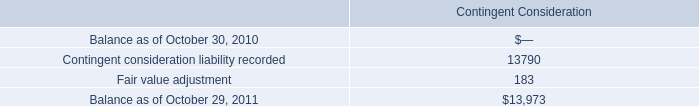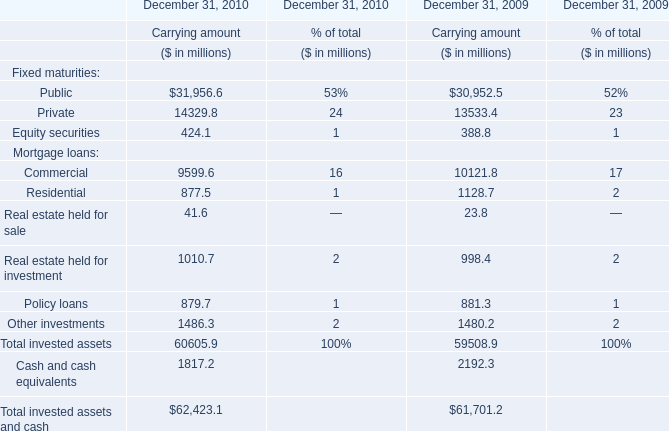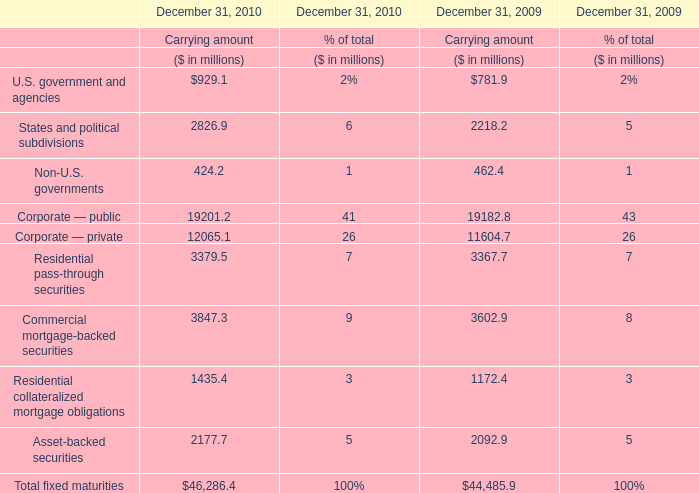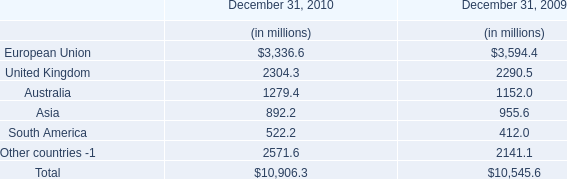What is the growing rate of Residential pass-through securities in the year with the most Corporate — private? (in %) 
Computations: ((3379.5 - 3367.7) / 3367.7)
Answer: 0.0035. 